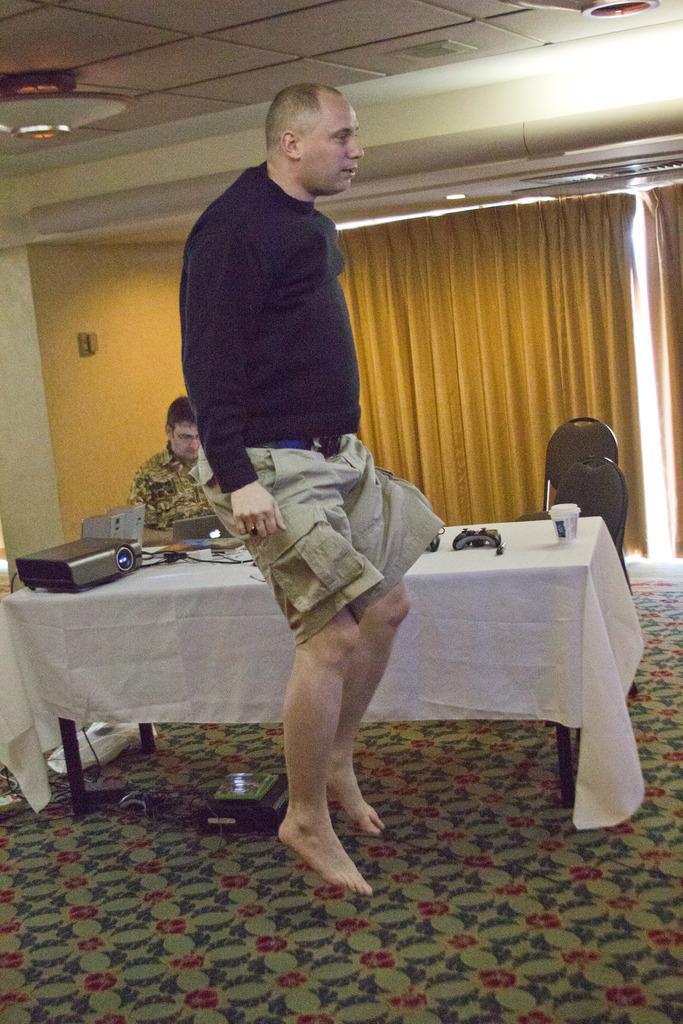Can you describe this image briefly? In this image I see 2 men in which this man is sitting and this man is in the air and I see the floor and I see a table on which there many things and I see 2 chairs over here. In the background I see the curtains and the wall and I see the ceiling. 